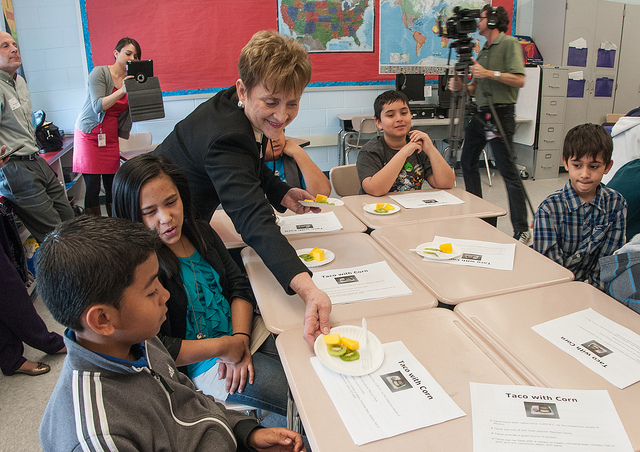<image>What kind of computer is featured in the picture? I don't know what kind of computer is featured in the picture. It can be a tablet, desktop, ipad or dell. What kind of computer is featured in the picture? I don't know what kind of computer is featured in the picture. It can be either a tablet, desktop, iPad or Dell. 